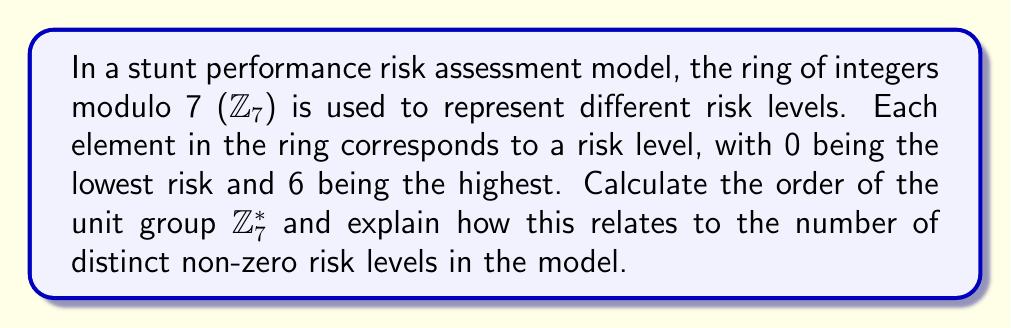Can you answer this question? To solve this problem, we need to follow these steps:

1) First, recall that in the ring $$\mathbb{Z}_7$$, the elements are {0, 1, 2, 3, 4, 5, 6}.

2) The unit group $$\mathbb{Z}_7^*$$ consists of all elements in $$\mathbb{Z}_7$$ that have multiplicative inverses. In a field like $$\mathbb{Z}_7$$, all non-zero elements are units.

3) Therefore, $$\mathbb{Z}_7^* = \{1, 2, 3, 4, 5, 6\}$$.

4) The order of a group is the number of elements in the group. So, the order of $$\mathbb{Z}_7^*$$ is 6.

5) This result is consistent with Euler's totient function $$\phi(n)$$, which for a prime $p$ is equal to $p-1$. Since 7 is prime, $$\phi(7) = 7-1 = 6$$.

6) In the context of the risk assessment model, this means there are 6 distinct non-zero risk levels. Each level corresponds to a unit in the ring, allowing for a cyclical representation of risk that could be useful in modeling the repetitive nature of stunt performances.

7) The fact that 7 is prime ensures that each non-zero risk level (1 through 6) can be uniquely mapped to any other through multiplication by a unit, providing flexibility in risk level transitions.
Answer: The order of the unit group $$\mathbb{Z}_7^*$$ is 6, corresponding to 6 distinct non-zero risk levels in the stunt performance risk assessment model. 